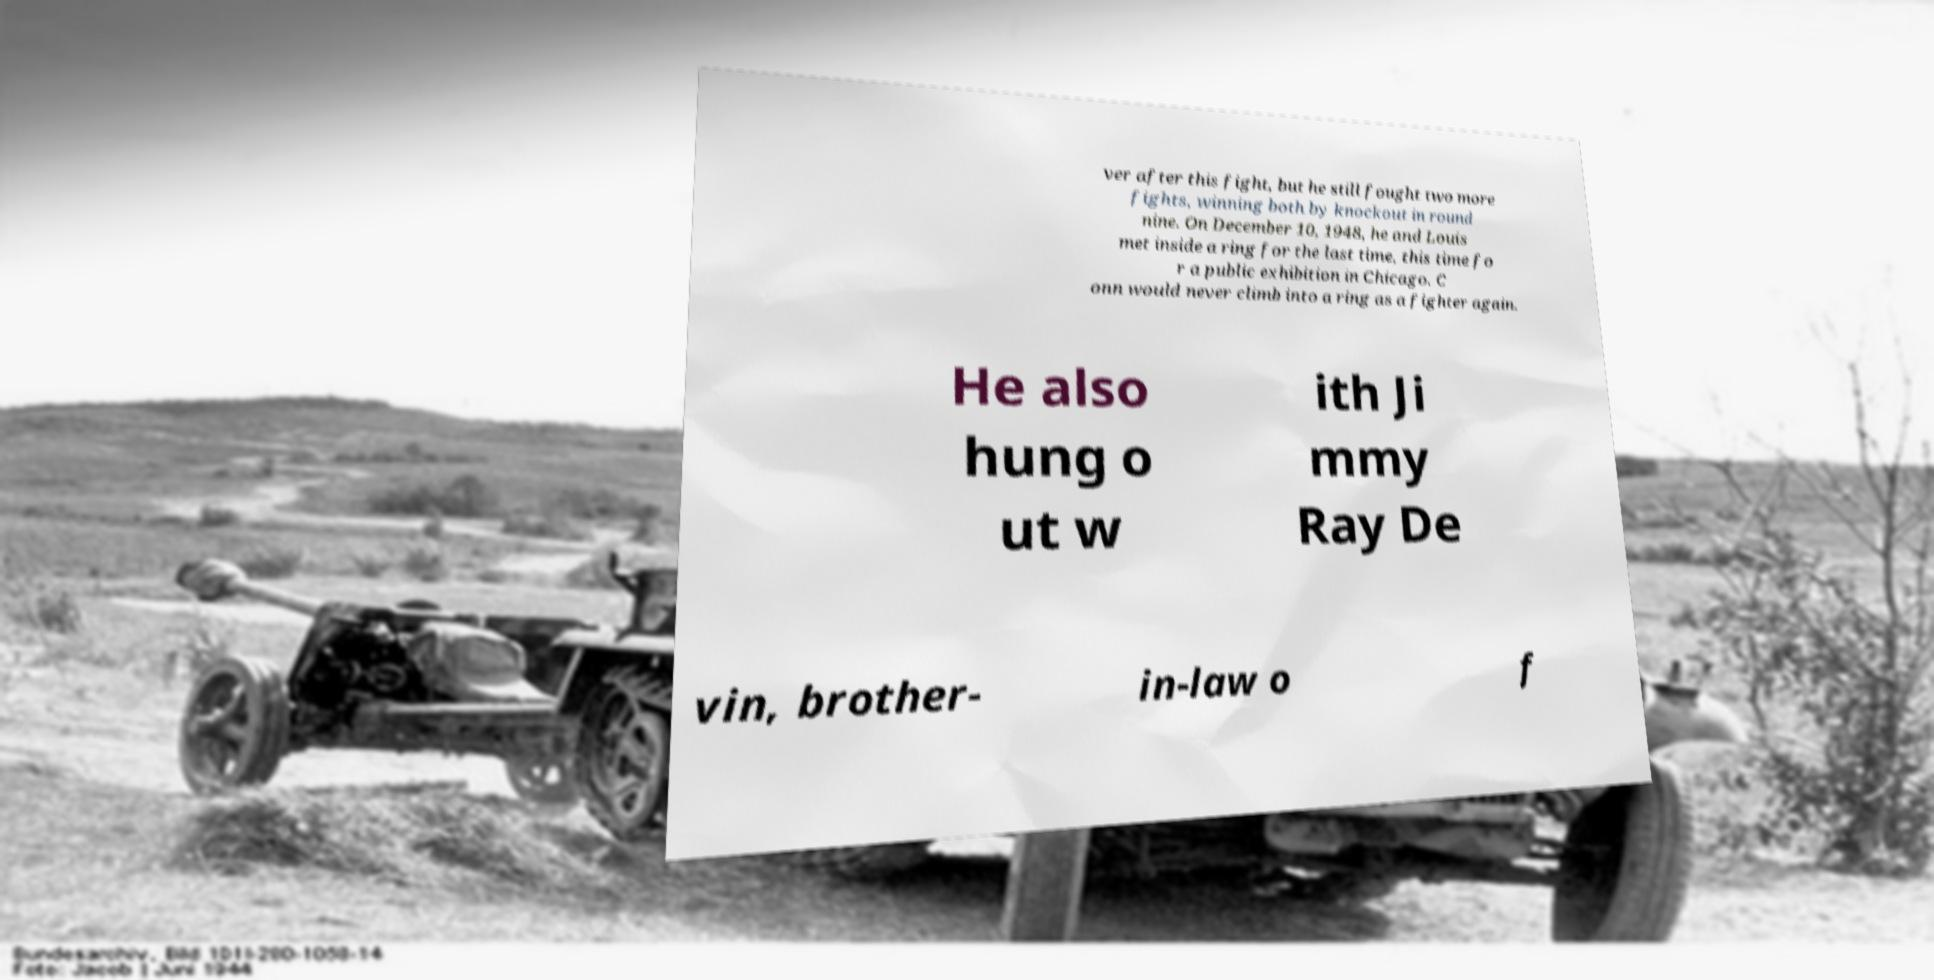What messages or text are displayed in this image? I need them in a readable, typed format. ver after this fight, but he still fought two more fights, winning both by knockout in round nine. On December 10, 1948, he and Louis met inside a ring for the last time, this time fo r a public exhibition in Chicago. C onn would never climb into a ring as a fighter again. He also hung o ut w ith Ji mmy Ray De vin, brother- in-law o f 